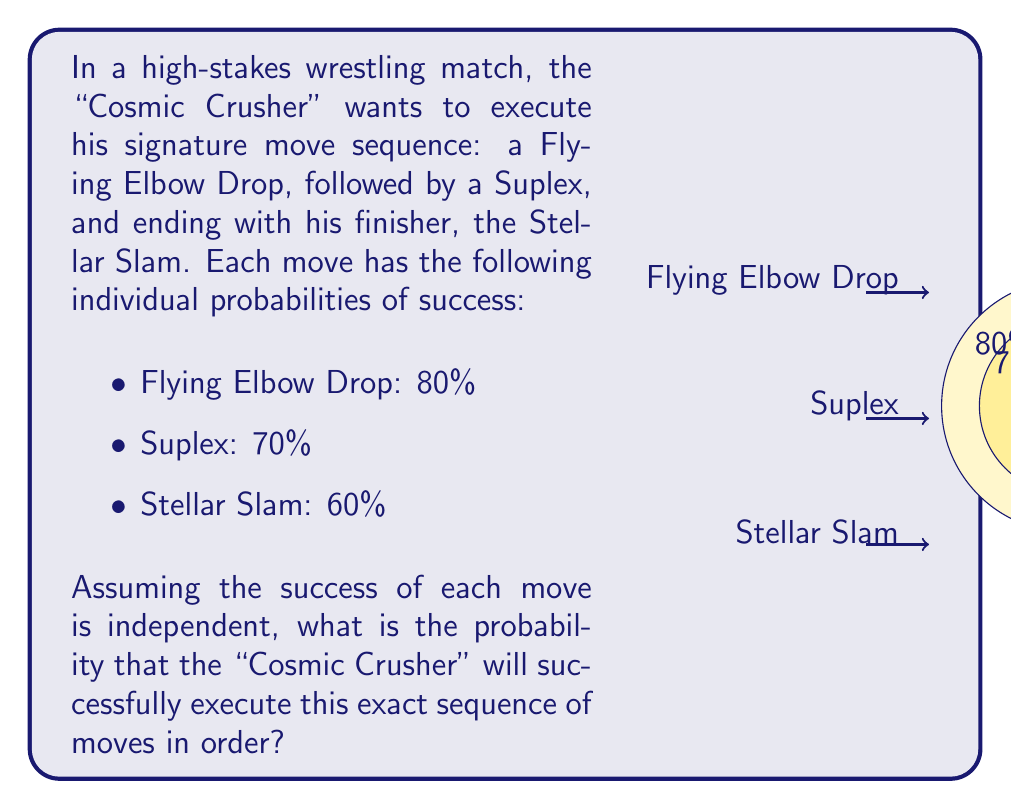Help me with this question. To solve this problem, we need to use the multiplication rule of probability for independent events. The probability of all events occurring in sequence is the product of their individual probabilities.

Let's break it down step-by-step:

1) Let's define our events:
   A = Flying Elbow Drop succeeds
   B = Suplex succeeds
   C = Stellar Slam succeeds

2) We're given the following probabilities:
   P(A) = 80% = 0.80
   P(B) = 70% = 0.70
   P(C) = 60% = 0.60

3) We want to find P(A and B and C), which is equivalent to P(A ∩ B ∩ C)

4) Since the events are independent, we can use the multiplication rule:

   $$P(A ∩ B ∩ C) = P(A) × P(B) × P(C)$$

5) Substituting our values:

   $$P(A ∩ B ∩ C) = 0.80 × 0.70 × 0.60$$

6) Calculating:

   $$P(A ∩ B ∩ C) = 0.336$$

7) Converting to a percentage:

   $$0.336 × 100\% = 33.6\%$$

Therefore, the probability of the "Cosmic Crusher" successfully executing this exact sequence of moves in order is 33.6%.
Answer: 33.6% 